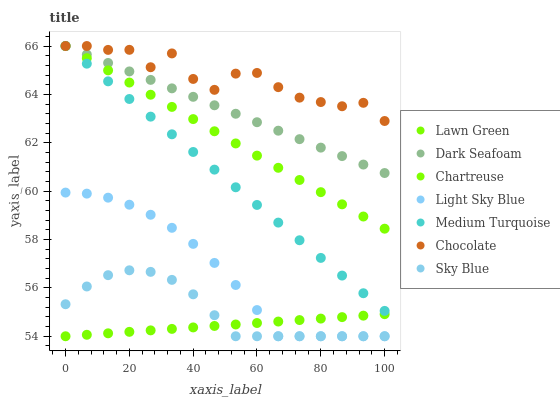Does Lawn Green have the minimum area under the curve?
Answer yes or no. Yes. Does Chocolate have the maximum area under the curve?
Answer yes or no. Yes. Does Chartreuse have the minimum area under the curve?
Answer yes or no. No. Does Chartreuse have the maximum area under the curve?
Answer yes or no. No. Is Dark Seafoam the smoothest?
Answer yes or no. Yes. Is Chocolate the roughest?
Answer yes or no. Yes. Is Chartreuse the smoothest?
Answer yes or no. No. Is Chartreuse the roughest?
Answer yes or no. No. Does Lawn Green have the lowest value?
Answer yes or no. Yes. Does Chartreuse have the lowest value?
Answer yes or no. No. Does Medium Turquoise have the highest value?
Answer yes or no. Yes. Does Light Sky Blue have the highest value?
Answer yes or no. No. Is Light Sky Blue less than Medium Turquoise?
Answer yes or no. Yes. Is Chocolate greater than Light Sky Blue?
Answer yes or no. Yes. Does Lawn Green intersect Light Sky Blue?
Answer yes or no. Yes. Is Lawn Green less than Light Sky Blue?
Answer yes or no. No. Is Lawn Green greater than Light Sky Blue?
Answer yes or no. No. Does Light Sky Blue intersect Medium Turquoise?
Answer yes or no. No. 